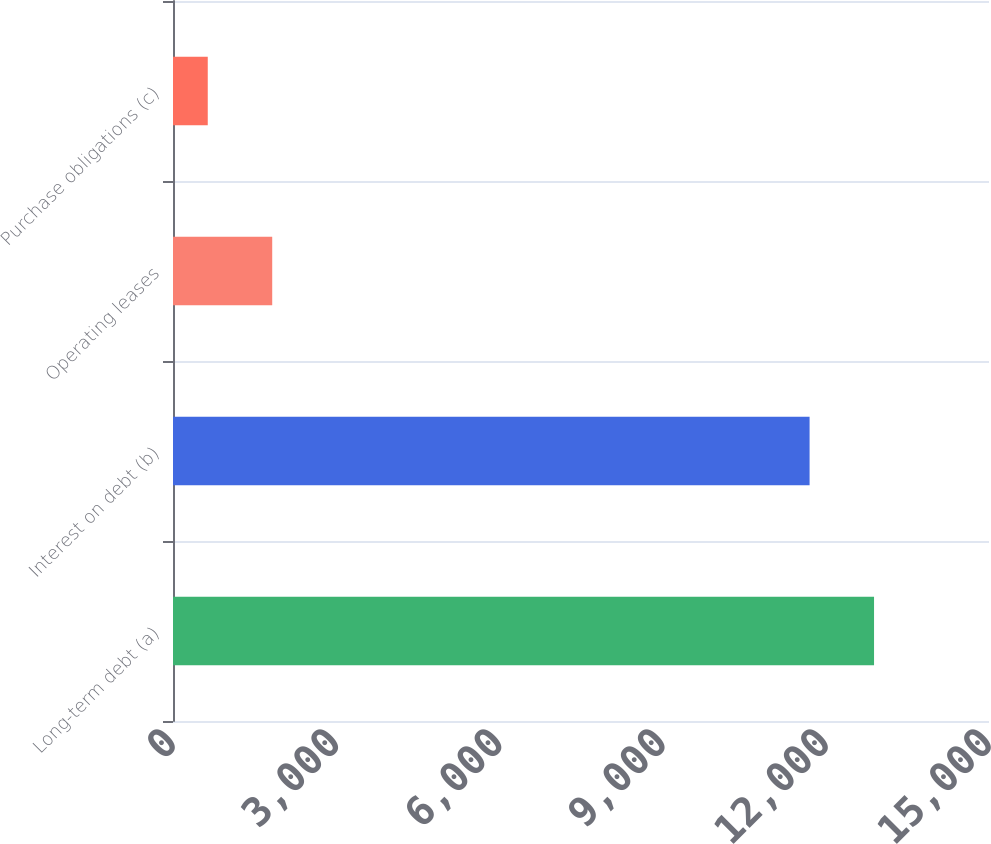Convert chart to OTSL. <chart><loc_0><loc_0><loc_500><loc_500><bar_chart><fcel>Long-term debt (a)<fcel>Interest on debt (b)<fcel>Operating leases<fcel>Purchase obligations (c)<nl><fcel>12886.8<fcel>11702<fcel>1823.8<fcel>639<nl></chart> 